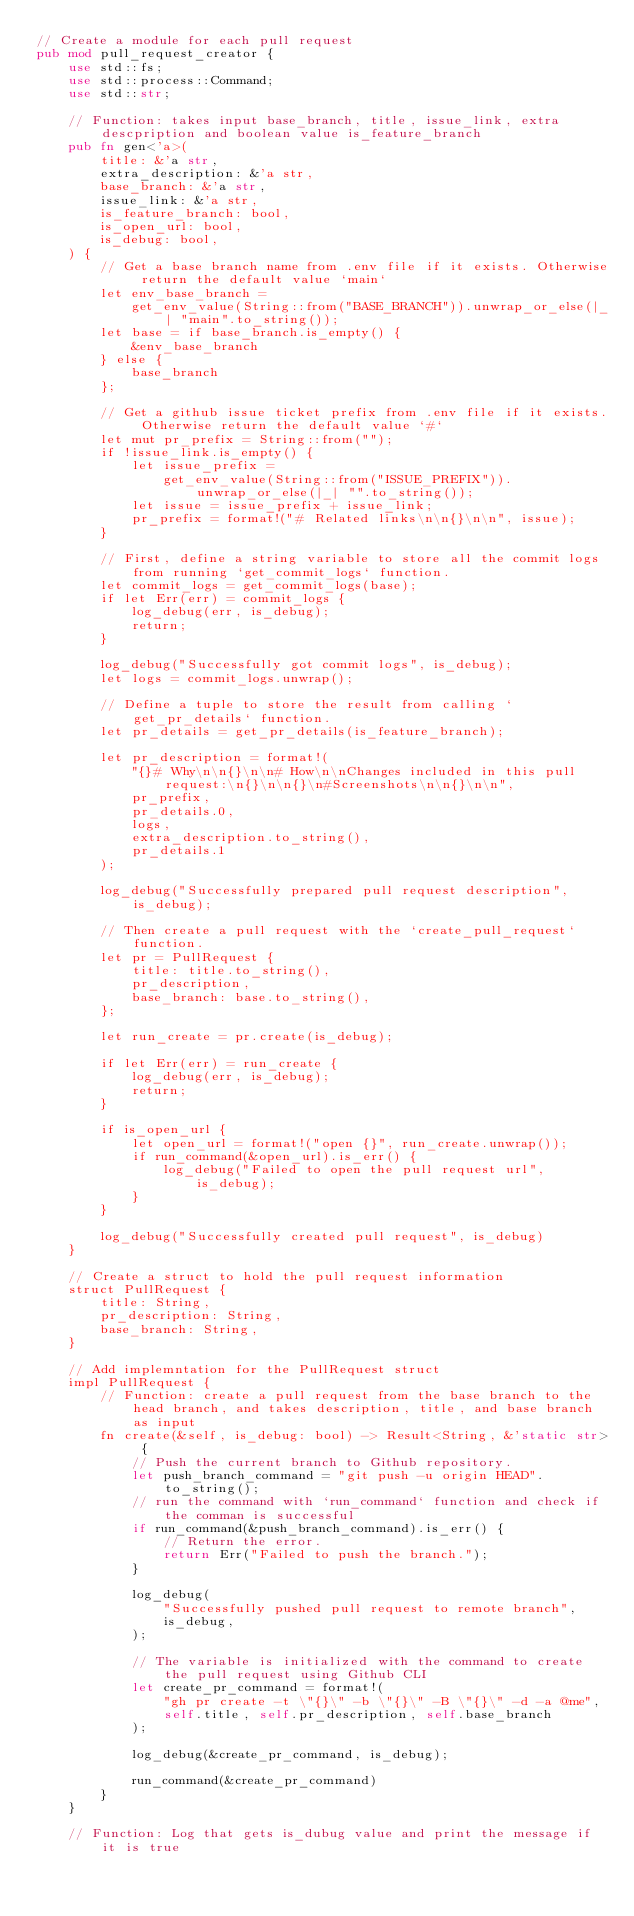<code> <loc_0><loc_0><loc_500><loc_500><_Rust_>// Create a module for each pull request
pub mod pull_request_creator {
    use std::fs;
    use std::process::Command;
    use std::str;

    // Function: takes input base_branch, title, issue_link, extra descpription and boolean value is_feature_branch
    pub fn gen<'a>(
        title: &'a str,
        extra_description: &'a str,
        base_branch: &'a str,
        issue_link: &'a str,
        is_feature_branch: bool,
        is_open_url: bool,
        is_debug: bool,
    ) {
        // Get a base branch name from .env file if it exists. Otherwise return the default value `main`
        let env_base_branch =
            get_env_value(String::from("BASE_BRANCH")).unwrap_or_else(|_| "main".to_string());
        let base = if base_branch.is_empty() {
            &env_base_branch
        } else {
            base_branch
        };

        // Get a github issue ticket prefix from .env file if it exists. Otherwise return the default value `#`
        let mut pr_prefix = String::from("");
        if !issue_link.is_empty() {
            let issue_prefix =
                get_env_value(String::from("ISSUE_PREFIX")).unwrap_or_else(|_| "".to_string());
            let issue = issue_prefix + issue_link;
            pr_prefix = format!("# Related links\n\n{}\n\n", issue);
        }

        // First, define a string variable to store all the commit logs from running `get_commit_logs` function.
        let commit_logs = get_commit_logs(base);
        if let Err(err) = commit_logs {
            log_debug(err, is_debug);
            return;
        }

        log_debug("Successfully got commit logs", is_debug);
        let logs = commit_logs.unwrap();

        // Define a tuple to store the result from calling `get_pr_details` function.
        let pr_details = get_pr_details(is_feature_branch);

        let pr_description = format!(
            "{}# Why\n\n{}\n\n# How\n\nChanges included in this pull request:\n{}\n\n{}\n#Screenshots\n\n{}\n\n",
            pr_prefix,
            pr_details.0,
            logs,
            extra_description.to_string(),
            pr_details.1
        );

        log_debug("Successfully prepared pull request description", is_debug);

        // Then create a pull request with the `create_pull_request` function.
        let pr = PullRequest {
            title: title.to_string(),
            pr_description,
            base_branch: base.to_string(),
        };

        let run_create = pr.create(is_debug);

        if let Err(err) = run_create {
            log_debug(err, is_debug);
            return;
        }

        if is_open_url {
            let open_url = format!("open {}", run_create.unwrap());
            if run_command(&open_url).is_err() {
                log_debug("Failed to open the pull request url", is_debug);
            }
        }

        log_debug("Successfully created pull request", is_debug)
    }

    // Create a struct to hold the pull request information
    struct PullRequest {
        title: String,
        pr_description: String,
        base_branch: String,
    }

    // Add implemntation for the PullRequest struct
    impl PullRequest {
        // Function: create a pull request from the base branch to the head branch, and takes description, title, and base branch as input
        fn create(&self, is_debug: bool) -> Result<String, &'static str> {
            // Push the current branch to Github repository.
            let push_branch_command = "git push -u origin HEAD".to_string();
            // run the command with `run_command` function and check if the comman is successful
            if run_command(&push_branch_command).is_err() {
                // Return the error.
                return Err("Failed to push the branch.");
            }

            log_debug(
                "Successfully pushed pull request to remote branch",
                is_debug,
            );

            // The variable is initialized with the command to create the pull request using Github CLI
            let create_pr_command = format!(
                "gh pr create -t \"{}\" -b \"{}\" -B \"{}\" -d -a @me",
                self.title, self.pr_description, self.base_branch
            );

            log_debug(&create_pr_command, is_debug);

            run_command(&create_pr_command)
        }
    }

    // Function: Log that gets is_dubug value and print the message if it is true</code> 